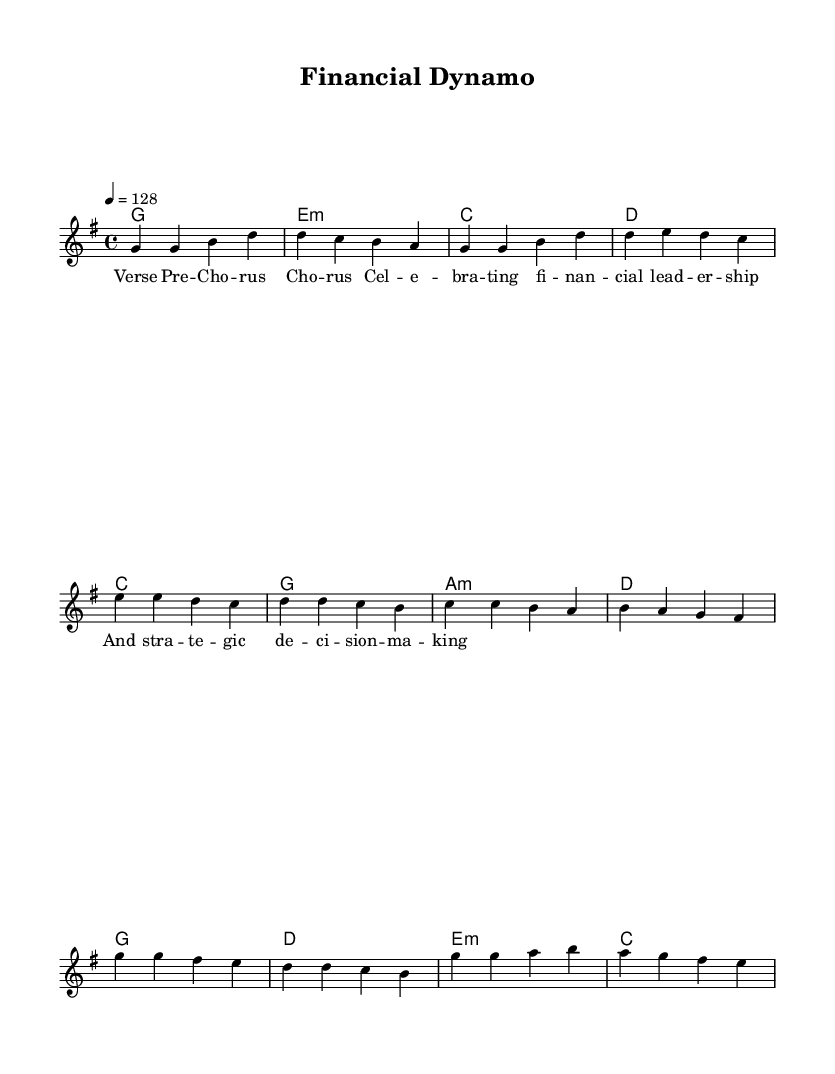What is the key signature of this music? The key signature is G major, which has one sharp.
Answer: G major What is the time signature of this music? The time signature is 4/4, meaning there are four beats in each measure.
Answer: 4/4 What is the tempo of this song? The tempo is indicated as quarter note equals 128 beats per minute.
Answer: 128 How many measures are in the chorus section? By analyzing the music, there are 4 measures indicated in the chorus section.
Answer: 4 What type of chords are used in the verse? In the verse, the chords are a combination of major and minor chords, specifically G major, E minor, C major, and D major.
Answer: Major and minor What is the lyrical theme celebrated in this anthem? The lyrics celebrate themes of financial leadership and strategic decision-making, emphasizing empowerment.
Answer: Financial leadership How does the pre-chorus relate to the verse musically? The pre-chorus musically connects to the verse by flowing from the chord progression of C major to G major, maintaining a similar melodic line.
Answer: Similar melodic line 